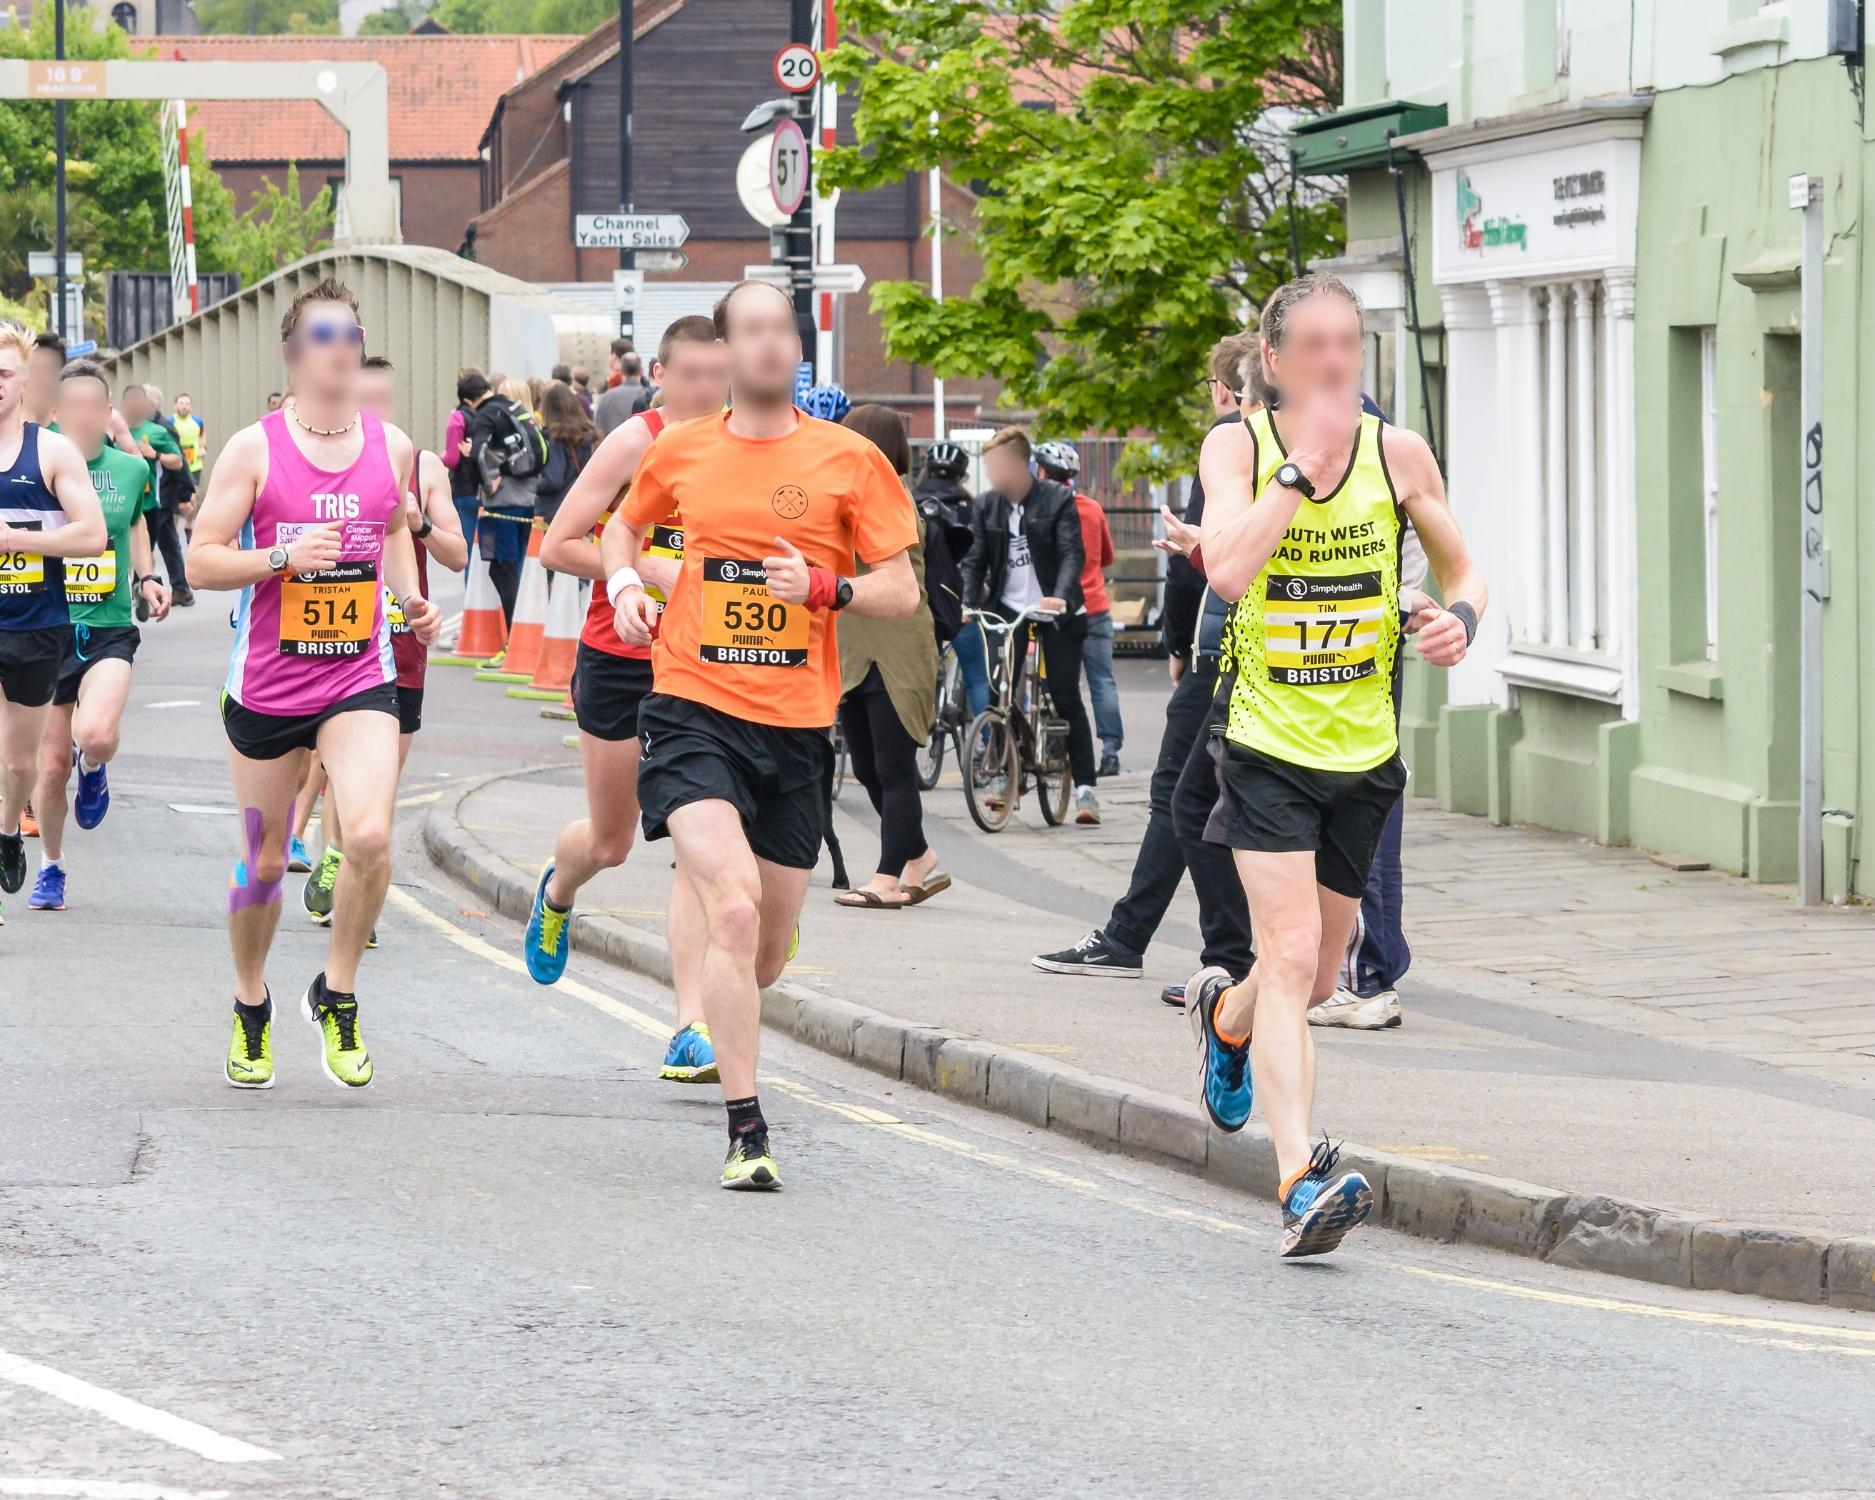What does this image suggest about the time of year the event is taking place? While the exact time of year cannot be determined solely from the image, the runners are dressed in lightweight, breathable clothing suitable for warmer weather, suggesting that the event could be taking place in late spring or summer. The presence of lush green leaves on the trees also supports this inference. 